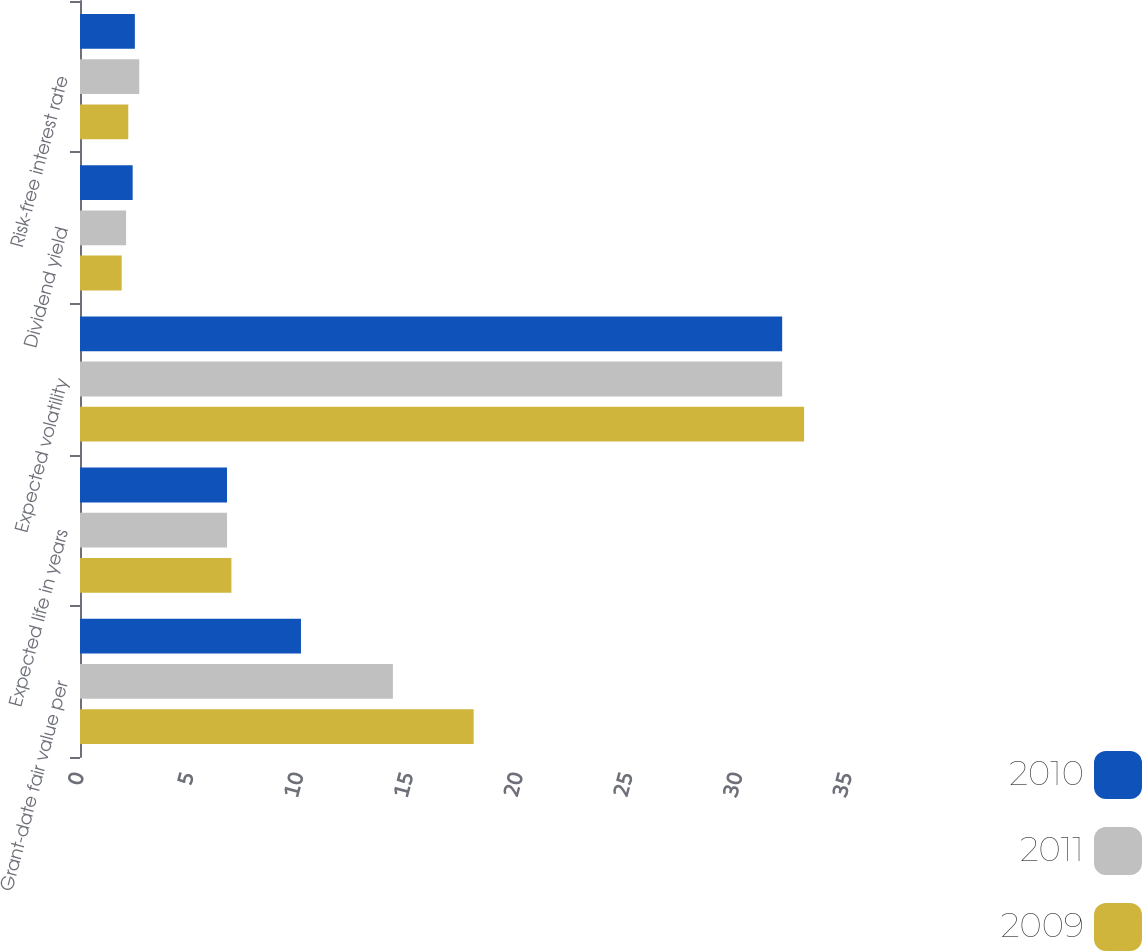Convert chart. <chart><loc_0><loc_0><loc_500><loc_500><stacked_bar_chart><ecel><fcel>Grant-date fair value per<fcel>Expected life in years<fcel>Expected volatility<fcel>Dividend yield<fcel>Risk-free interest rate<nl><fcel>2010<fcel>10.07<fcel>6.7<fcel>32<fcel>2.4<fcel>2.5<nl><fcel>2011<fcel>14.26<fcel>6.7<fcel>32<fcel>2.1<fcel>2.7<nl><fcel>2009<fcel>17.94<fcel>6.9<fcel>33<fcel>1.9<fcel>2.2<nl></chart> 